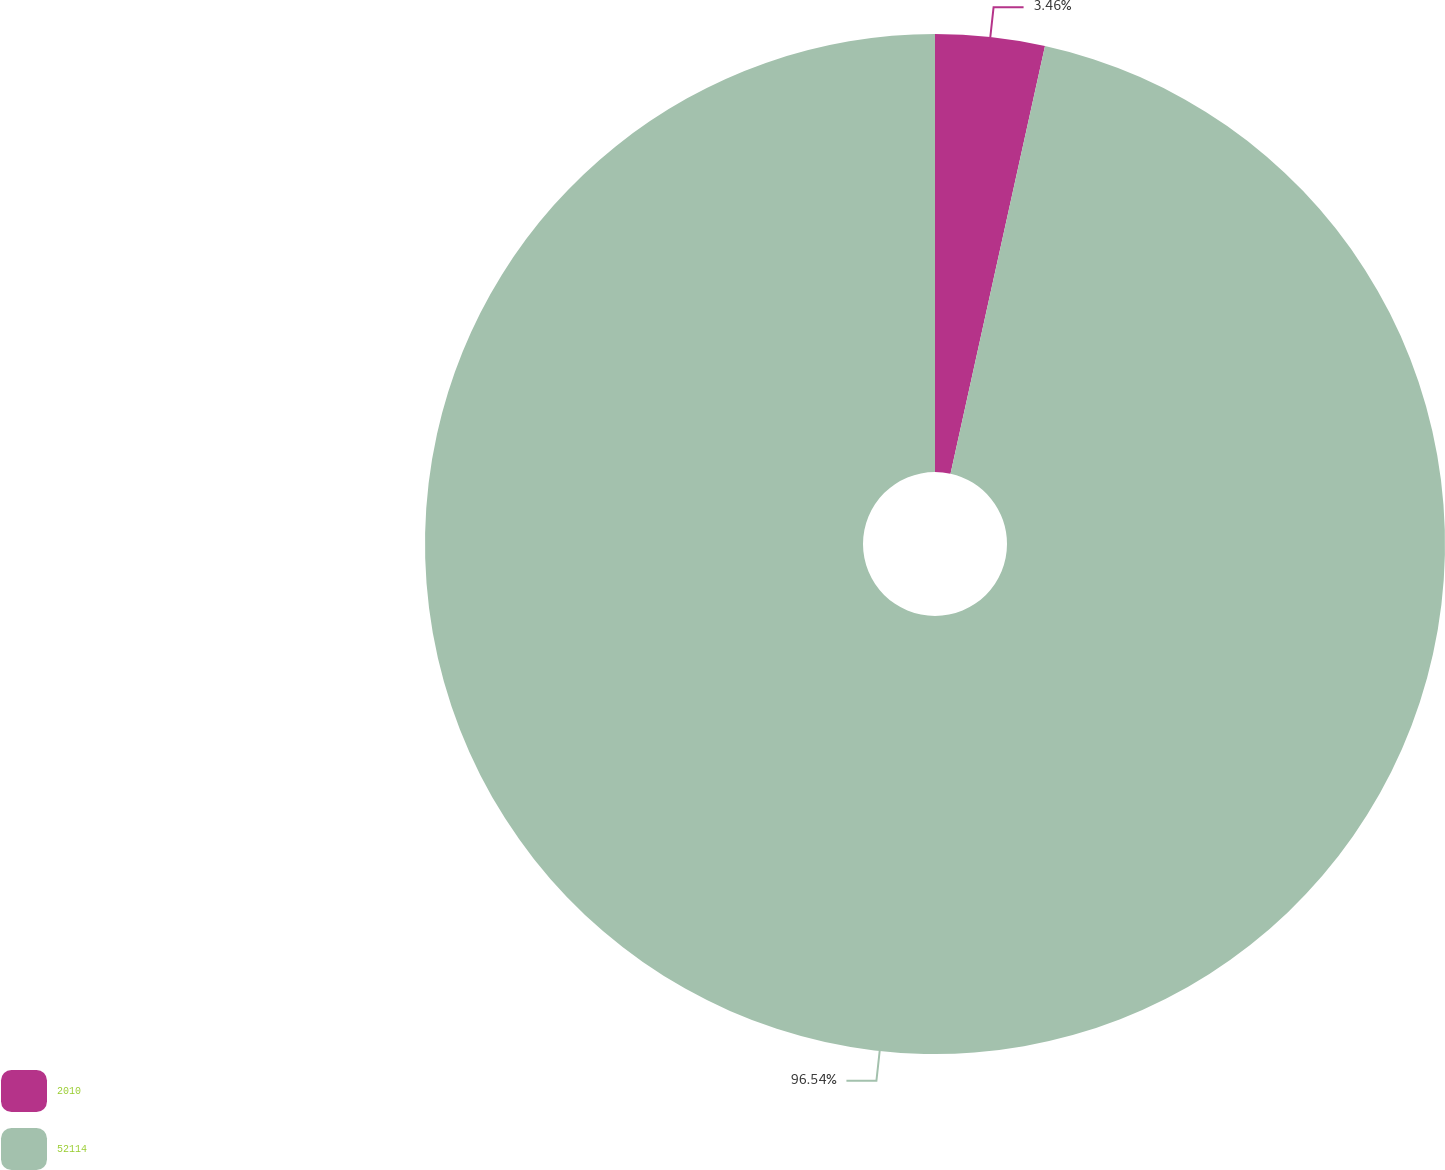Convert chart to OTSL. <chart><loc_0><loc_0><loc_500><loc_500><pie_chart><fcel>2010<fcel>52114<nl><fcel>3.46%<fcel>96.54%<nl></chart> 